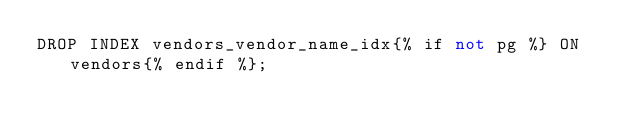<code> <loc_0><loc_0><loc_500><loc_500><_SQL_>DROP INDEX vendors_vendor_name_idx{% if not pg %} ON vendors{% endif %};
</code> 